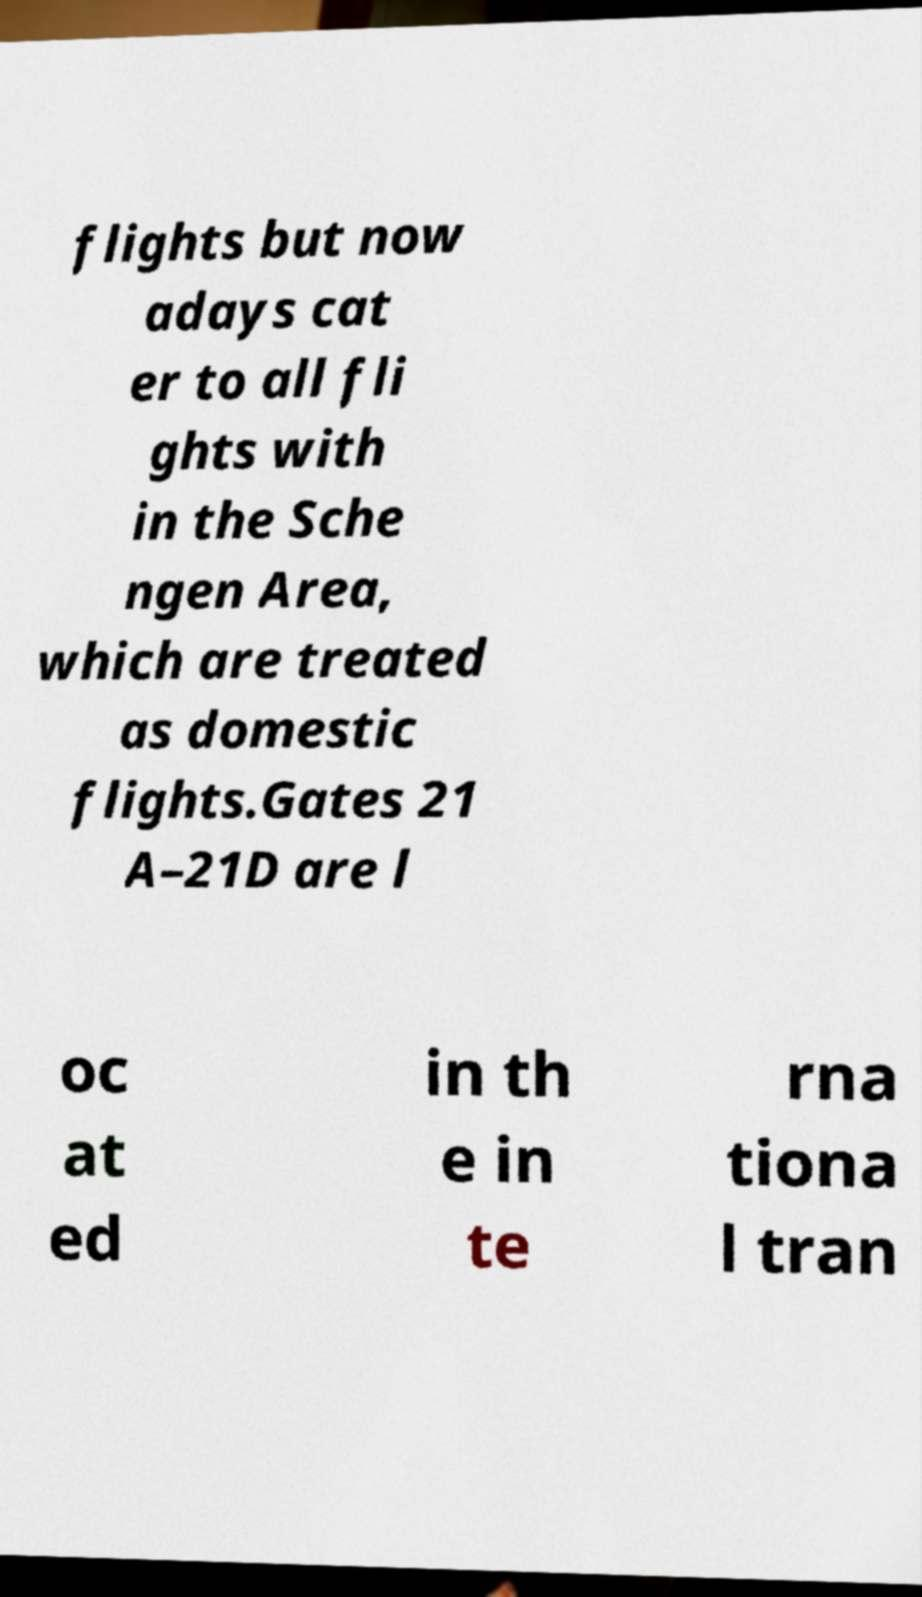Can you read and provide the text displayed in the image?This photo seems to have some interesting text. Can you extract and type it out for me? flights but now adays cat er to all fli ghts with in the Sche ngen Area, which are treated as domestic flights.Gates 21 A–21D are l oc at ed in th e in te rna tiona l tran 